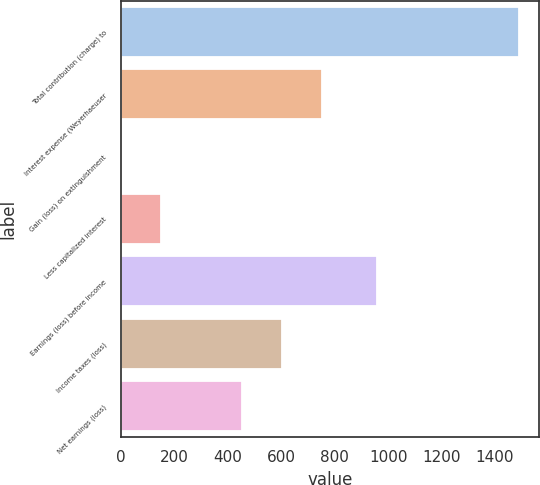Convert chart to OTSL. <chart><loc_0><loc_0><loc_500><loc_500><bar_chart><fcel>Total contribution (charge) to<fcel>Interest expense (Weyerhaeuser<fcel>Gain (loss) on extinguishment<fcel>Less capitalized interest<fcel>Earnings (loss) before income<fcel>Income taxes (loss)<fcel>Net earnings (loss)<nl><fcel>1489<fcel>750.4<fcel>2<fcel>150.7<fcel>958<fcel>601.7<fcel>453<nl></chart> 